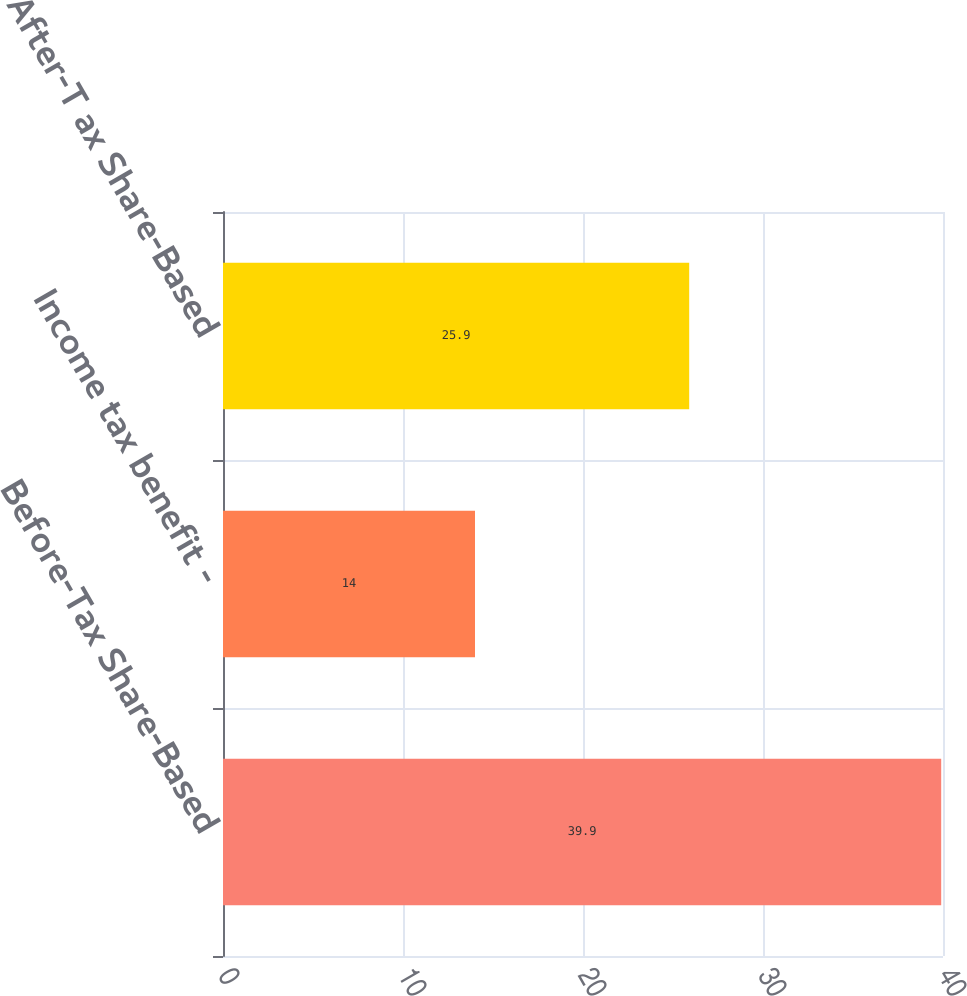Convert chart. <chart><loc_0><loc_0><loc_500><loc_500><bar_chart><fcel>Before-Tax Share-Based<fcel>Income tax benefit -<fcel>After-T ax Share-Based<nl><fcel>39.9<fcel>14<fcel>25.9<nl></chart> 